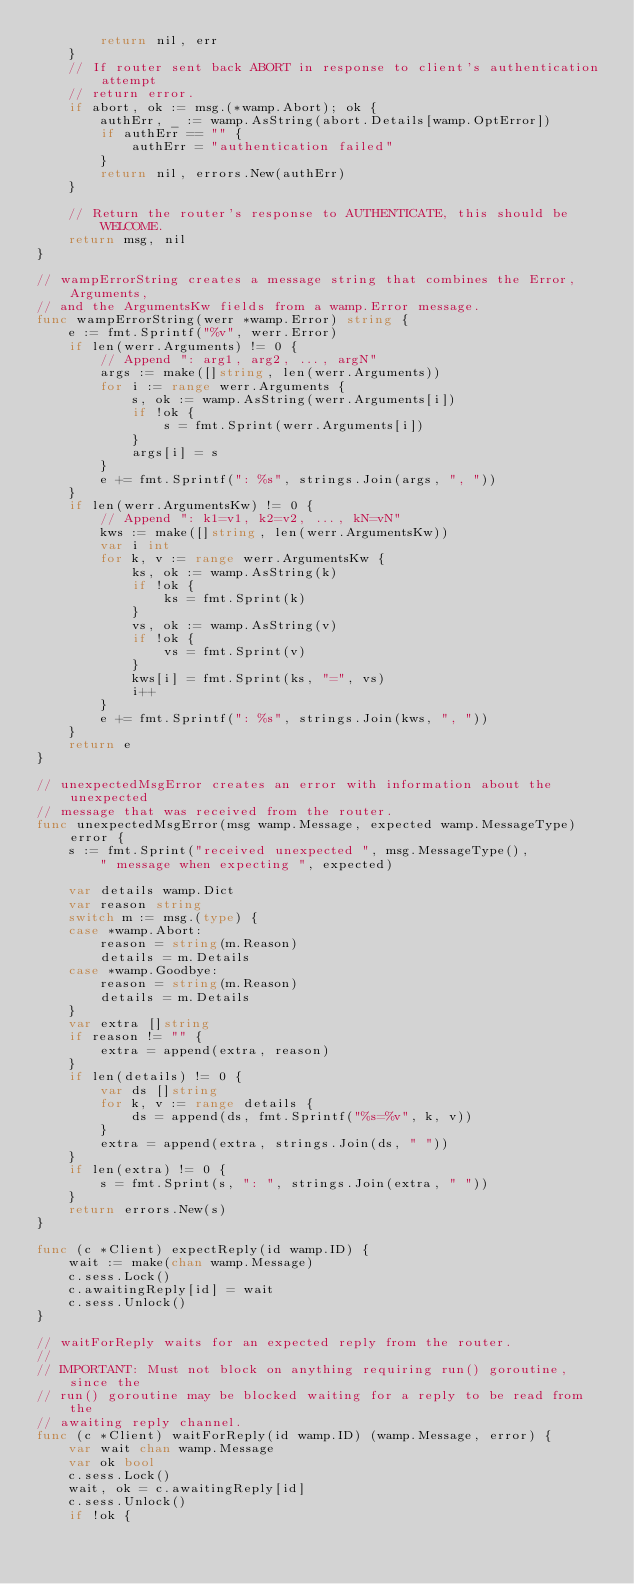Convert code to text. <code><loc_0><loc_0><loc_500><loc_500><_Go_>		return nil, err
	}
	// If router sent back ABORT in response to client's authentication attempt
	// return error.
	if abort, ok := msg.(*wamp.Abort); ok {
		authErr, _ := wamp.AsString(abort.Details[wamp.OptError])
		if authErr == "" {
			authErr = "authentication failed"
		}
		return nil, errors.New(authErr)
	}

	// Return the router's response to AUTHENTICATE, this should be WELCOME.
	return msg, nil
}

// wampErrorString creates a message string that combines the Error, Arguments,
// and the ArgumentsKw fields from a wamp.Error message.
func wampErrorString(werr *wamp.Error) string {
	e := fmt.Sprintf("%v", werr.Error)
	if len(werr.Arguments) != 0 {
		// Append ": arg1, arg2, ..., argN"
		args := make([]string, len(werr.Arguments))
		for i := range werr.Arguments {
			s, ok := wamp.AsString(werr.Arguments[i])
			if !ok {
				s = fmt.Sprint(werr.Arguments[i])
			}
			args[i] = s
		}
		e += fmt.Sprintf(": %s", strings.Join(args, ", "))
	}
	if len(werr.ArgumentsKw) != 0 {
		// Append ": k1=v1, k2=v2, ..., kN=vN"
		kws := make([]string, len(werr.ArgumentsKw))
		var i int
		for k, v := range werr.ArgumentsKw {
			ks, ok := wamp.AsString(k)
			if !ok {
				ks = fmt.Sprint(k)
			}
			vs, ok := wamp.AsString(v)
			if !ok {
				vs = fmt.Sprint(v)
			}
			kws[i] = fmt.Sprint(ks, "=", vs)
			i++
		}
		e += fmt.Sprintf(": %s", strings.Join(kws, ", "))
	}
	return e
}

// unexpectedMsgError creates an error with information about the unexpected
// message that was received from the router.
func unexpectedMsgError(msg wamp.Message, expected wamp.MessageType) error {
	s := fmt.Sprint("received unexpected ", msg.MessageType(),
		" message when expecting ", expected)

	var details wamp.Dict
	var reason string
	switch m := msg.(type) {
	case *wamp.Abort:
		reason = string(m.Reason)
		details = m.Details
	case *wamp.Goodbye:
		reason = string(m.Reason)
		details = m.Details
	}
	var extra []string
	if reason != "" {
		extra = append(extra, reason)
	}
	if len(details) != 0 {
		var ds []string
		for k, v := range details {
			ds = append(ds, fmt.Sprintf("%s=%v", k, v))
		}
		extra = append(extra, strings.Join(ds, " "))
	}
	if len(extra) != 0 {
		s = fmt.Sprint(s, ": ", strings.Join(extra, " "))
	}
	return errors.New(s)
}

func (c *Client) expectReply(id wamp.ID) {
	wait := make(chan wamp.Message)
	c.sess.Lock()
	c.awaitingReply[id] = wait
	c.sess.Unlock()
}

// waitForReply waits for an expected reply from the router.
//
// IMPORTANT: Must not block on anything requiring run() goroutine, since the
// run() goroutine may be blocked waiting for a reply to be read from the
// awaiting reply channel.
func (c *Client) waitForReply(id wamp.ID) (wamp.Message, error) {
	var wait chan wamp.Message
	var ok bool
	c.sess.Lock()
	wait, ok = c.awaitingReply[id]
	c.sess.Unlock()
	if !ok {</code> 